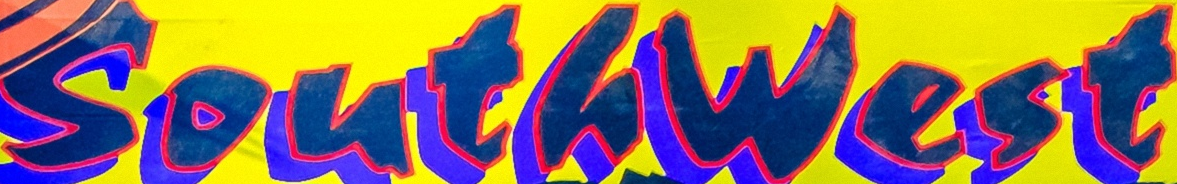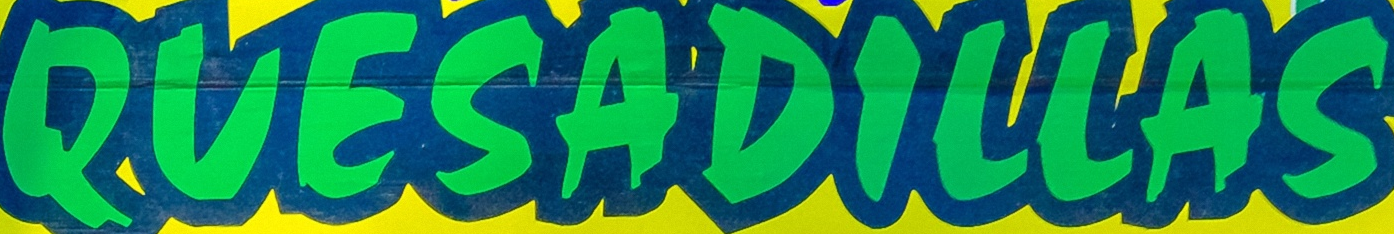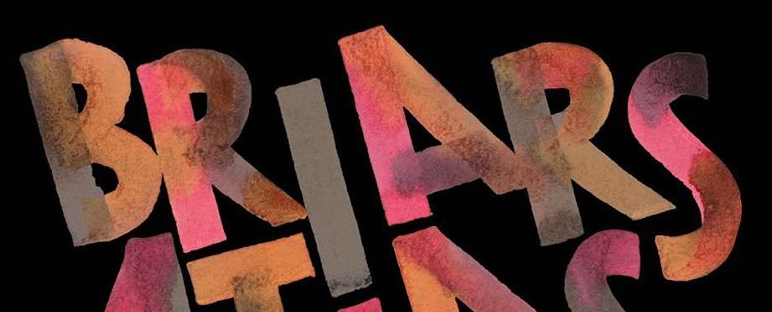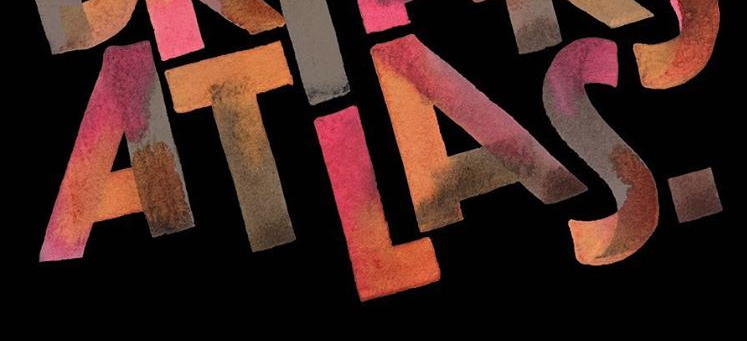Identify the words shown in these images in order, separated by a semicolon. Southwest; QUESADILLAS; BRIARS; ATLAS. 